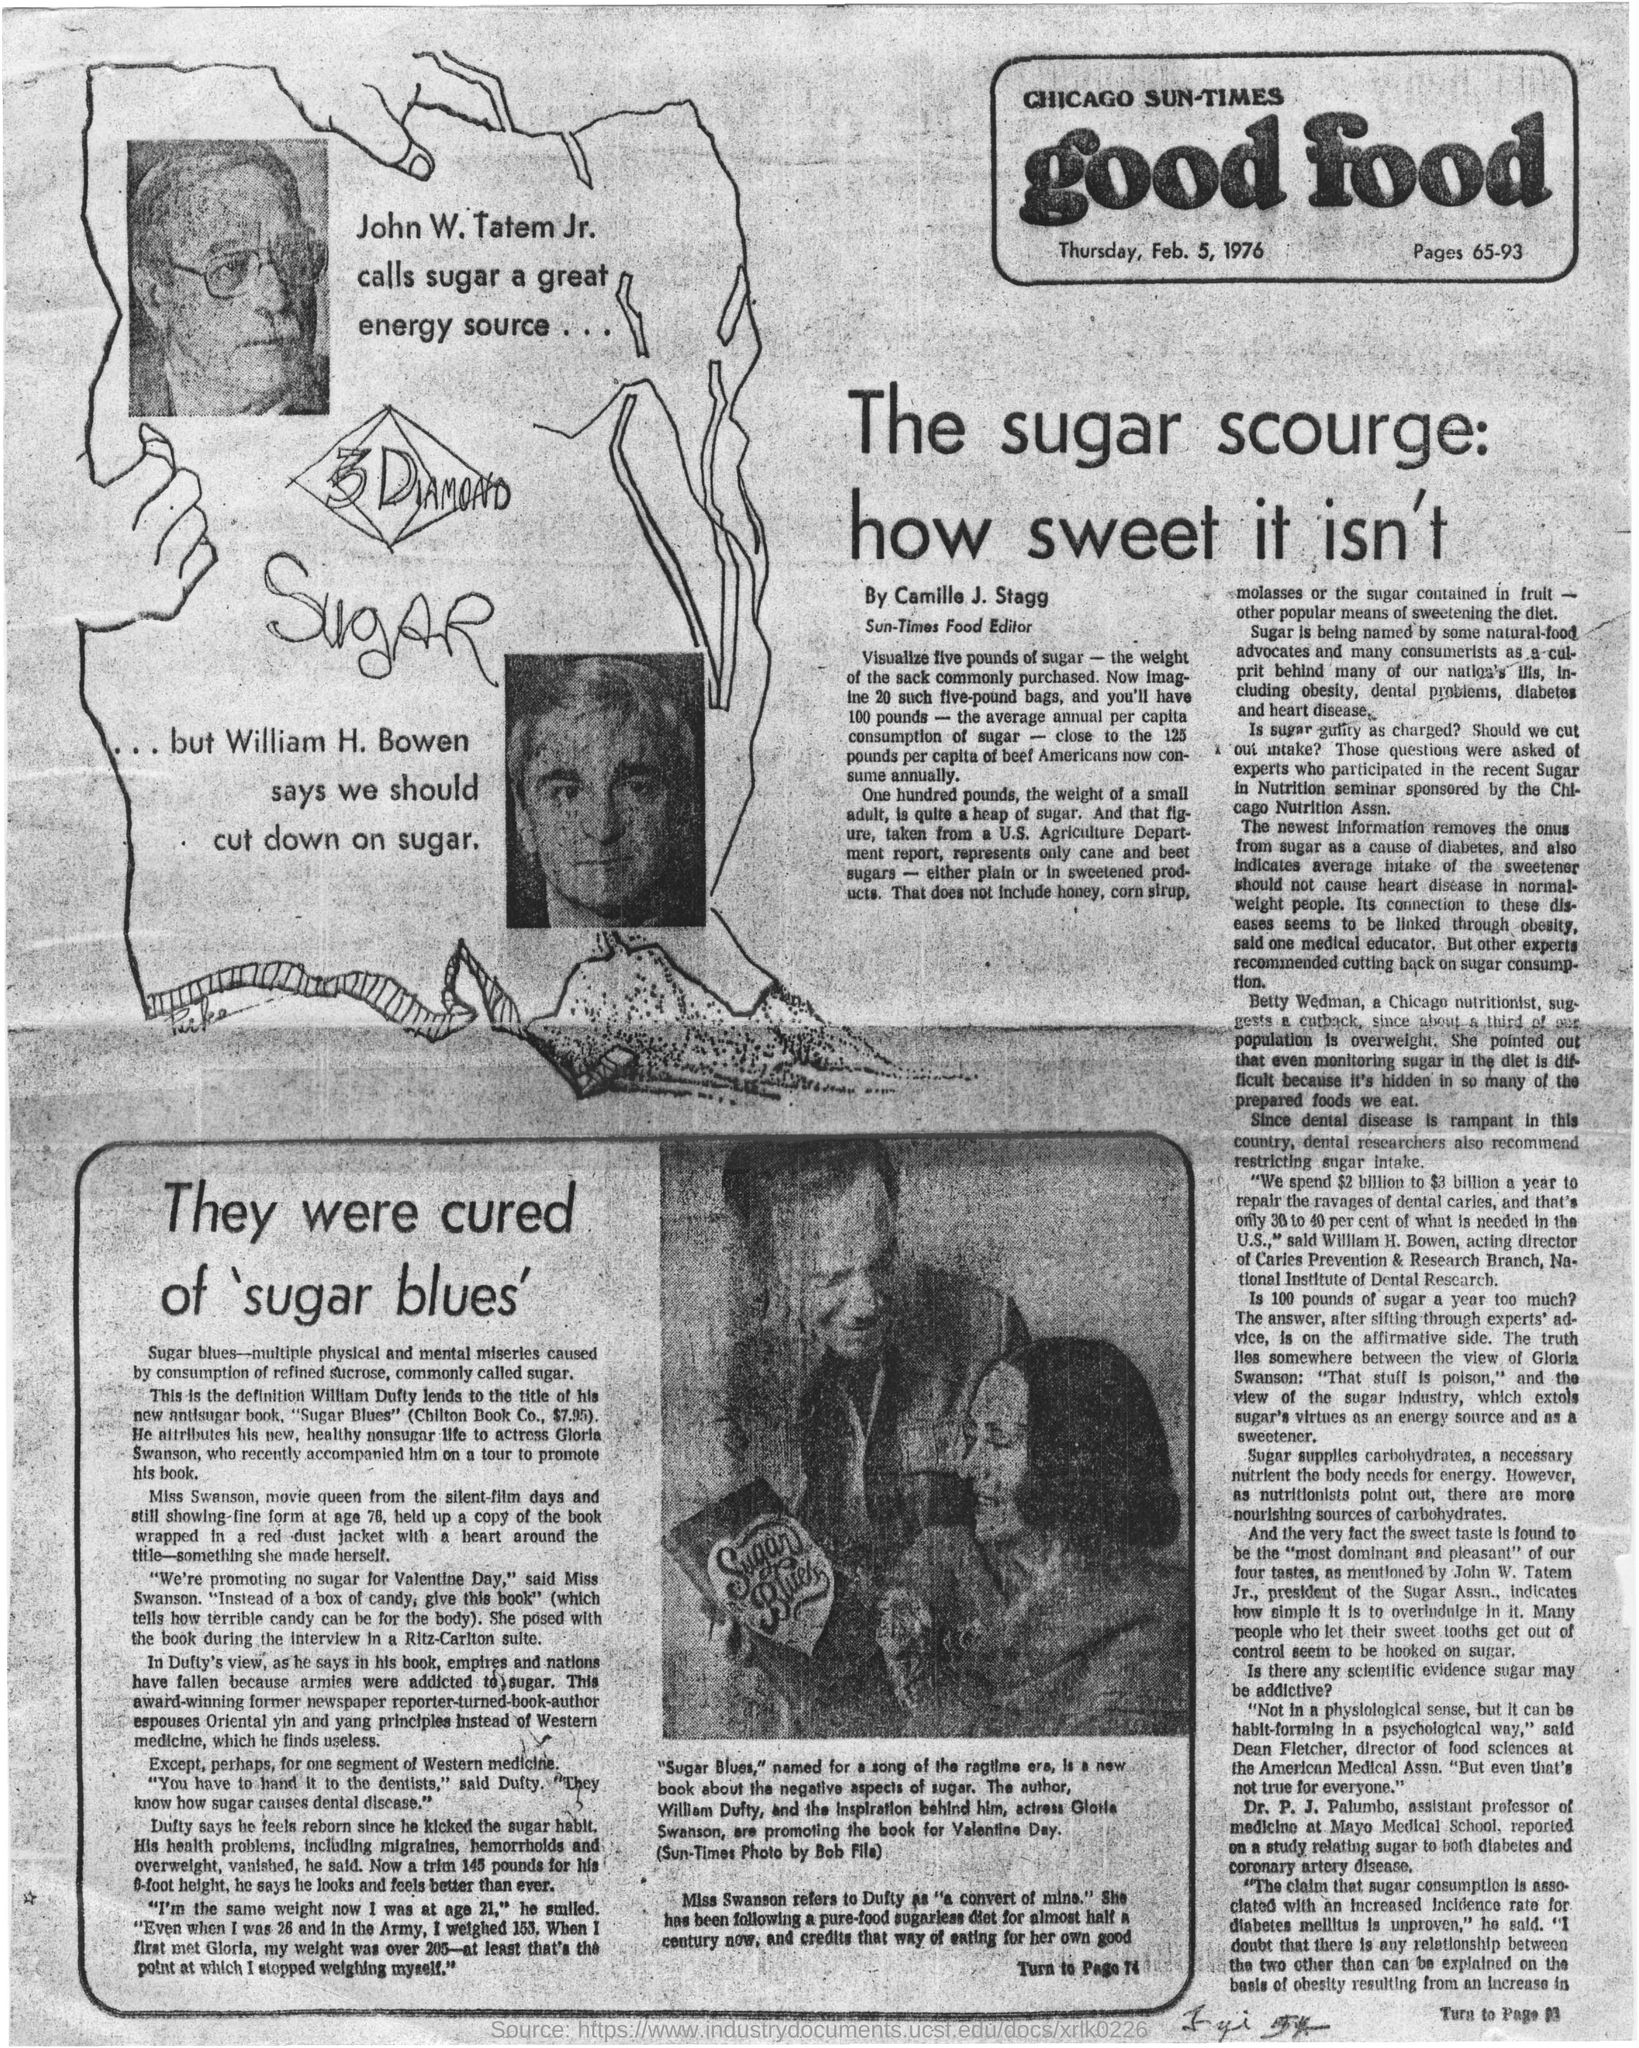What is the name of the newspaper?
Your response must be concise. Chicago Sun-times. Who called sugar a great energy source?
Keep it short and to the point. John W. Tatem, Jr. What did William H. Bowen said?
Keep it short and to the point. We should cut down on sugar. Who is Sun-Times Food Editor?
Your answer should be very brief. Camille J. Stagg. What does Sugar supplies?
Offer a terse response. Carbohydrates. Who is the director of food sciences at the American Medical Assn?
Your response must be concise. Dean Fletcher. What is the date mentioned in this newspaper?
Your answer should be very brief. Thursday, Feb. 5, 1976. Who suggests that we should cut down on sugar?
Offer a terse response. William H. Bowen. 